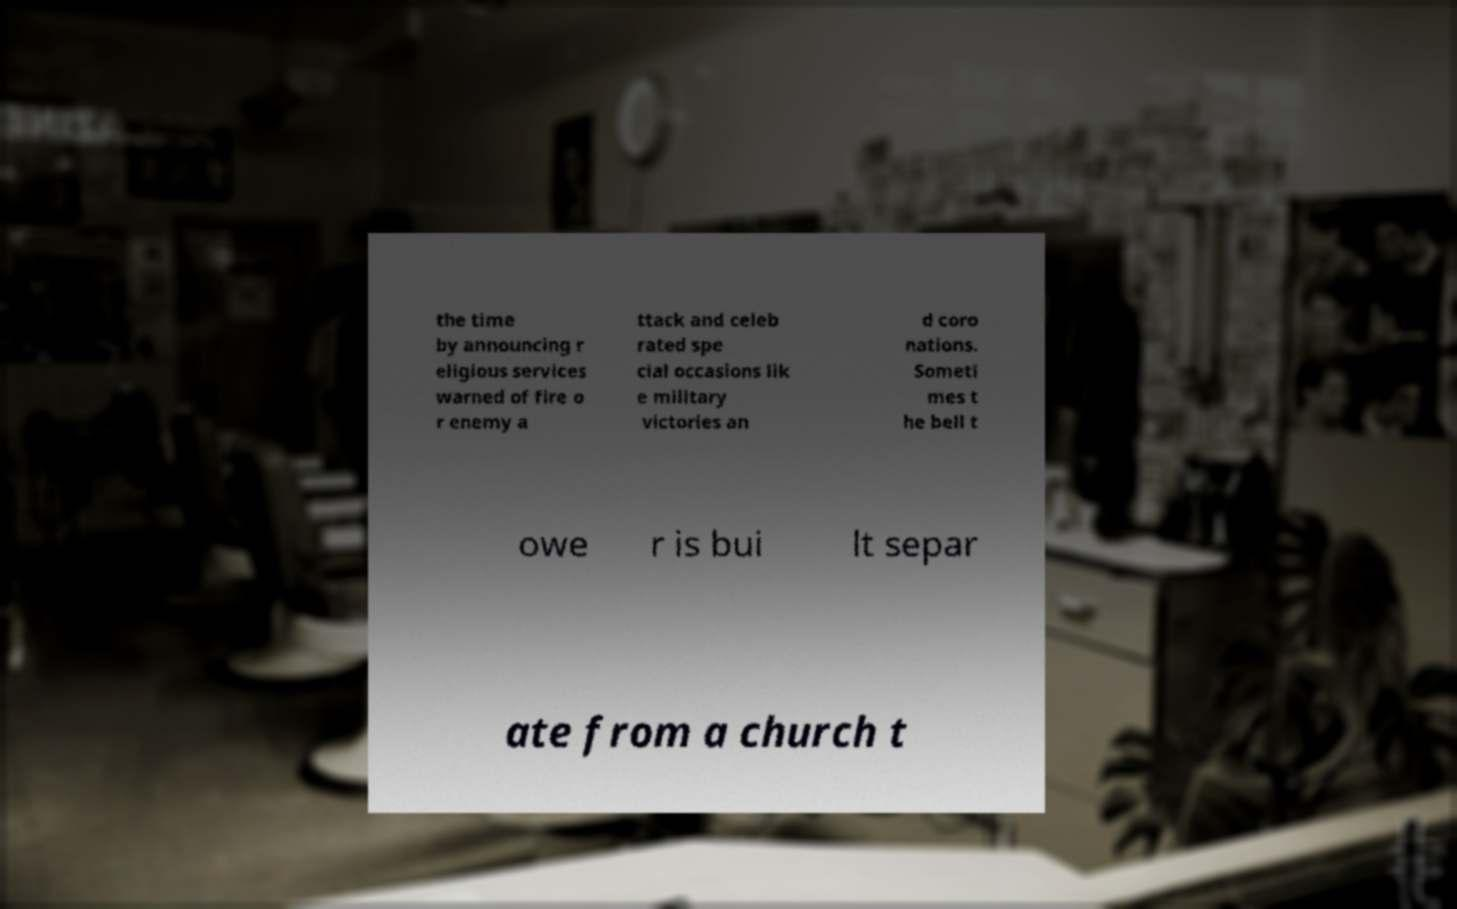For documentation purposes, I need the text within this image transcribed. Could you provide that? the time by announcing r eligious services warned of fire o r enemy a ttack and celeb rated spe cial occasions lik e military victories an d coro nations. Someti mes t he bell t owe r is bui lt separ ate from a church t 